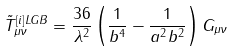<formula> <loc_0><loc_0><loc_500><loc_500>\tilde { T } ^ { \left [ i \right ] L G B } _ { \mu \nu } = \frac { 3 6 } { \lambda ^ { 2 } } \left ( \frac { 1 } { b ^ { 4 } } - \frac { 1 } { a ^ { 2 } b ^ { 2 } } \right ) G _ { \mu \nu }</formula> 